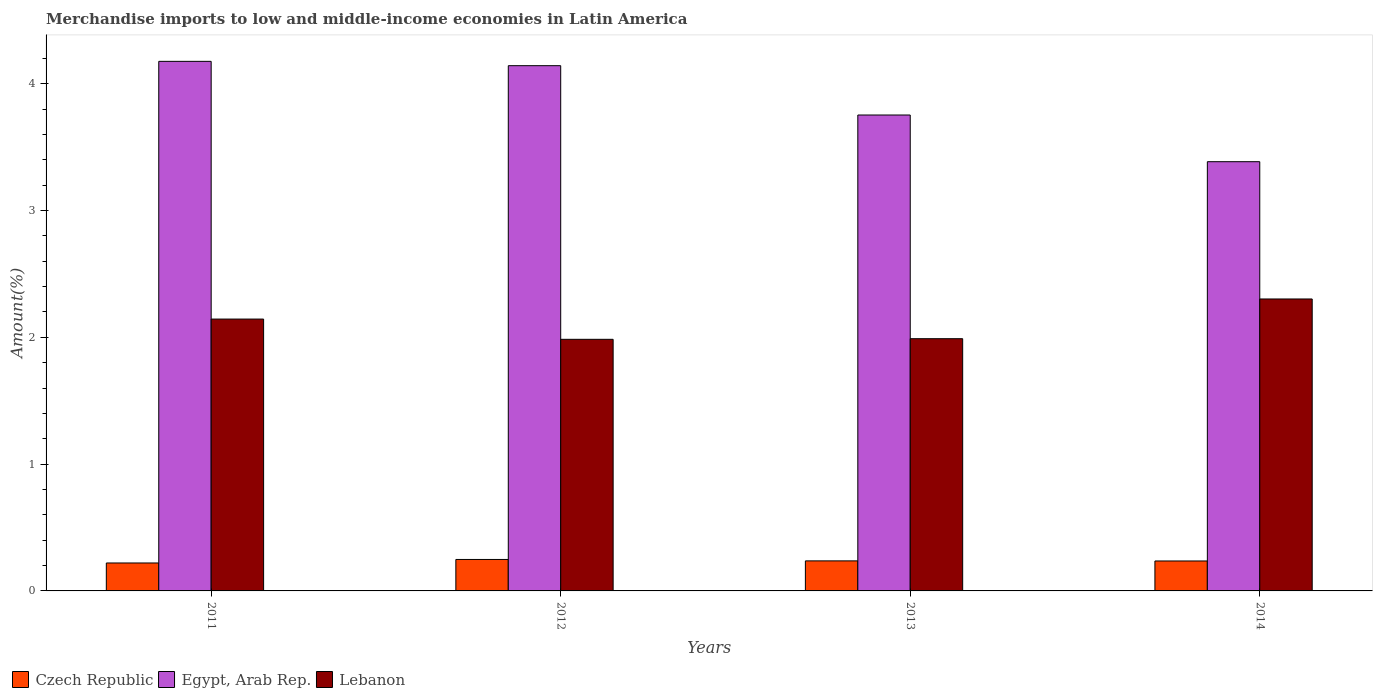How many different coloured bars are there?
Offer a very short reply. 3. How many groups of bars are there?
Ensure brevity in your answer.  4. How many bars are there on the 4th tick from the left?
Your answer should be compact. 3. In how many cases, is the number of bars for a given year not equal to the number of legend labels?
Give a very brief answer. 0. What is the percentage of amount earned from merchandise imports in Czech Republic in 2011?
Give a very brief answer. 0.22. Across all years, what is the maximum percentage of amount earned from merchandise imports in Czech Republic?
Provide a succinct answer. 0.25. Across all years, what is the minimum percentage of amount earned from merchandise imports in Czech Republic?
Provide a succinct answer. 0.22. In which year was the percentage of amount earned from merchandise imports in Lebanon maximum?
Your answer should be very brief. 2014. What is the total percentage of amount earned from merchandise imports in Lebanon in the graph?
Provide a short and direct response. 8.42. What is the difference between the percentage of amount earned from merchandise imports in Czech Republic in 2012 and that in 2014?
Keep it short and to the point. 0.01. What is the difference between the percentage of amount earned from merchandise imports in Lebanon in 2014 and the percentage of amount earned from merchandise imports in Egypt, Arab Rep. in 2013?
Keep it short and to the point. -1.45. What is the average percentage of amount earned from merchandise imports in Egypt, Arab Rep. per year?
Provide a succinct answer. 3.86. In the year 2012, what is the difference between the percentage of amount earned from merchandise imports in Lebanon and percentage of amount earned from merchandise imports in Czech Republic?
Your answer should be compact. 1.74. In how many years, is the percentage of amount earned from merchandise imports in Lebanon greater than 1.2 %?
Provide a succinct answer. 4. What is the ratio of the percentage of amount earned from merchandise imports in Egypt, Arab Rep. in 2011 to that in 2012?
Your response must be concise. 1.01. Is the percentage of amount earned from merchandise imports in Czech Republic in 2011 less than that in 2012?
Ensure brevity in your answer.  Yes. What is the difference between the highest and the second highest percentage of amount earned from merchandise imports in Czech Republic?
Offer a terse response. 0.01. What is the difference between the highest and the lowest percentage of amount earned from merchandise imports in Egypt, Arab Rep.?
Your answer should be very brief. 0.79. Is the sum of the percentage of amount earned from merchandise imports in Lebanon in 2011 and 2013 greater than the maximum percentage of amount earned from merchandise imports in Egypt, Arab Rep. across all years?
Provide a succinct answer. No. What does the 3rd bar from the left in 2012 represents?
Your response must be concise. Lebanon. What does the 1st bar from the right in 2011 represents?
Give a very brief answer. Lebanon. Is it the case that in every year, the sum of the percentage of amount earned from merchandise imports in Egypt, Arab Rep. and percentage of amount earned from merchandise imports in Lebanon is greater than the percentage of amount earned from merchandise imports in Czech Republic?
Your response must be concise. Yes. Are all the bars in the graph horizontal?
Offer a very short reply. No. How many years are there in the graph?
Keep it short and to the point. 4. Does the graph contain grids?
Your answer should be compact. No. How are the legend labels stacked?
Your answer should be compact. Horizontal. What is the title of the graph?
Your response must be concise. Merchandise imports to low and middle-income economies in Latin America. Does "New Zealand" appear as one of the legend labels in the graph?
Provide a succinct answer. No. What is the label or title of the X-axis?
Ensure brevity in your answer.  Years. What is the label or title of the Y-axis?
Ensure brevity in your answer.  Amount(%). What is the Amount(%) of Czech Republic in 2011?
Offer a terse response. 0.22. What is the Amount(%) of Egypt, Arab Rep. in 2011?
Offer a very short reply. 4.18. What is the Amount(%) in Lebanon in 2011?
Your response must be concise. 2.14. What is the Amount(%) of Czech Republic in 2012?
Offer a very short reply. 0.25. What is the Amount(%) of Egypt, Arab Rep. in 2012?
Ensure brevity in your answer.  4.14. What is the Amount(%) in Lebanon in 2012?
Give a very brief answer. 1.98. What is the Amount(%) in Czech Republic in 2013?
Offer a terse response. 0.24. What is the Amount(%) in Egypt, Arab Rep. in 2013?
Offer a very short reply. 3.75. What is the Amount(%) of Lebanon in 2013?
Give a very brief answer. 1.99. What is the Amount(%) in Czech Republic in 2014?
Provide a short and direct response. 0.24. What is the Amount(%) in Egypt, Arab Rep. in 2014?
Keep it short and to the point. 3.39. What is the Amount(%) of Lebanon in 2014?
Ensure brevity in your answer.  2.3. Across all years, what is the maximum Amount(%) in Czech Republic?
Make the answer very short. 0.25. Across all years, what is the maximum Amount(%) in Egypt, Arab Rep.?
Keep it short and to the point. 4.18. Across all years, what is the maximum Amount(%) of Lebanon?
Your answer should be compact. 2.3. Across all years, what is the minimum Amount(%) of Czech Republic?
Offer a very short reply. 0.22. Across all years, what is the minimum Amount(%) of Egypt, Arab Rep.?
Give a very brief answer. 3.39. Across all years, what is the minimum Amount(%) of Lebanon?
Offer a terse response. 1.98. What is the total Amount(%) in Czech Republic in the graph?
Ensure brevity in your answer.  0.94. What is the total Amount(%) in Egypt, Arab Rep. in the graph?
Give a very brief answer. 15.46. What is the total Amount(%) of Lebanon in the graph?
Keep it short and to the point. 8.42. What is the difference between the Amount(%) in Czech Republic in 2011 and that in 2012?
Ensure brevity in your answer.  -0.03. What is the difference between the Amount(%) of Egypt, Arab Rep. in 2011 and that in 2012?
Offer a terse response. 0.03. What is the difference between the Amount(%) of Lebanon in 2011 and that in 2012?
Your answer should be compact. 0.16. What is the difference between the Amount(%) in Czech Republic in 2011 and that in 2013?
Offer a terse response. -0.02. What is the difference between the Amount(%) in Egypt, Arab Rep. in 2011 and that in 2013?
Offer a terse response. 0.42. What is the difference between the Amount(%) in Lebanon in 2011 and that in 2013?
Make the answer very short. 0.15. What is the difference between the Amount(%) of Czech Republic in 2011 and that in 2014?
Offer a terse response. -0.02. What is the difference between the Amount(%) in Egypt, Arab Rep. in 2011 and that in 2014?
Offer a very short reply. 0.79. What is the difference between the Amount(%) of Lebanon in 2011 and that in 2014?
Your answer should be compact. -0.16. What is the difference between the Amount(%) of Czech Republic in 2012 and that in 2013?
Make the answer very short. 0.01. What is the difference between the Amount(%) in Egypt, Arab Rep. in 2012 and that in 2013?
Offer a terse response. 0.39. What is the difference between the Amount(%) of Lebanon in 2012 and that in 2013?
Provide a succinct answer. -0.01. What is the difference between the Amount(%) of Czech Republic in 2012 and that in 2014?
Offer a terse response. 0.01. What is the difference between the Amount(%) of Egypt, Arab Rep. in 2012 and that in 2014?
Provide a short and direct response. 0.76. What is the difference between the Amount(%) of Lebanon in 2012 and that in 2014?
Offer a terse response. -0.32. What is the difference between the Amount(%) in Czech Republic in 2013 and that in 2014?
Offer a very short reply. 0. What is the difference between the Amount(%) in Egypt, Arab Rep. in 2013 and that in 2014?
Your answer should be very brief. 0.37. What is the difference between the Amount(%) in Lebanon in 2013 and that in 2014?
Your answer should be compact. -0.31. What is the difference between the Amount(%) of Czech Republic in 2011 and the Amount(%) of Egypt, Arab Rep. in 2012?
Ensure brevity in your answer.  -3.92. What is the difference between the Amount(%) in Czech Republic in 2011 and the Amount(%) in Lebanon in 2012?
Give a very brief answer. -1.76. What is the difference between the Amount(%) in Egypt, Arab Rep. in 2011 and the Amount(%) in Lebanon in 2012?
Provide a short and direct response. 2.19. What is the difference between the Amount(%) of Czech Republic in 2011 and the Amount(%) of Egypt, Arab Rep. in 2013?
Provide a short and direct response. -3.53. What is the difference between the Amount(%) of Czech Republic in 2011 and the Amount(%) of Lebanon in 2013?
Give a very brief answer. -1.77. What is the difference between the Amount(%) of Egypt, Arab Rep. in 2011 and the Amount(%) of Lebanon in 2013?
Your answer should be very brief. 2.19. What is the difference between the Amount(%) in Czech Republic in 2011 and the Amount(%) in Egypt, Arab Rep. in 2014?
Your answer should be compact. -3.16. What is the difference between the Amount(%) in Czech Republic in 2011 and the Amount(%) in Lebanon in 2014?
Provide a short and direct response. -2.08. What is the difference between the Amount(%) of Egypt, Arab Rep. in 2011 and the Amount(%) of Lebanon in 2014?
Your answer should be very brief. 1.87. What is the difference between the Amount(%) of Czech Republic in 2012 and the Amount(%) of Egypt, Arab Rep. in 2013?
Provide a short and direct response. -3.51. What is the difference between the Amount(%) in Czech Republic in 2012 and the Amount(%) in Lebanon in 2013?
Your answer should be compact. -1.74. What is the difference between the Amount(%) of Egypt, Arab Rep. in 2012 and the Amount(%) of Lebanon in 2013?
Your response must be concise. 2.15. What is the difference between the Amount(%) of Czech Republic in 2012 and the Amount(%) of Egypt, Arab Rep. in 2014?
Give a very brief answer. -3.14. What is the difference between the Amount(%) of Czech Republic in 2012 and the Amount(%) of Lebanon in 2014?
Keep it short and to the point. -2.05. What is the difference between the Amount(%) in Egypt, Arab Rep. in 2012 and the Amount(%) in Lebanon in 2014?
Your response must be concise. 1.84. What is the difference between the Amount(%) of Czech Republic in 2013 and the Amount(%) of Egypt, Arab Rep. in 2014?
Offer a very short reply. -3.15. What is the difference between the Amount(%) of Czech Republic in 2013 and the Amount(%) of Lebanon in 2014?
Keep it short and to the point. -2.07. What is the difference between the Amount(%) in Egypt, Arab Rep. in 2013 and the Amount(%) in Lebanon in 2014?
Offer a very short reply. 1.45. What is the average Amount(%) of Czech Republic per year?
Give a very brief answer. 0.24. What is the average Amount(%) of Egypt, Arab Rep. per year?
Give a very brief answer. 3.86. What is the average Amount(%) of Lebanon per year?
Keep it short and to the point. 2.1. In the year 2011, what is the difference between the Amount(%) in Czech Republic and Amount(%) in Egypt, Arab Rep.?
Keep it short and to the point. -3.96. In the year 2011, what is the difference between the Amount(%) of Czech Republic and Amount(%) of Lebanon?
Ensure brevity in your answer.  -1.92. In the year 2011, what is the difference between the Amount(%) in Egypt, Arab Rep. and Amount(%) in Lebanon?
Ensure brevity in your answer.  2.03. In the year 2012, what is the difference between the Amount(%) of Czech Republic and Amount(%) of Egypt, Arab Rep.?
Make the answer very short. -3.89. In the year 2012, what is the difference between the Amount(%) in Czech Republic and Amount(%) in Lebanon?
Keep it short and to the point. -1.74. In the year 2012, what is the difference between the Amount(%) in Egypt, Arab Rep. and Amount(%) in Lebanon?
Your answer should be very brief. 2.16. In the year 2013, what is the difference between the Amount(%) in Czech Republic and Amount(%) in Egypt, Arab Rep.?
Make the answer very short. -3.52. In the year 2013, what is the difference between the Amount(%) of Czech Republic and Amount(%) of Lebanon?
Keep it short and to the point. -1.75. In the year 2013, what is the difference between the Amount(%) in Egypt, Arab Rep. and Amount(%) in Lebanon?
Offer a terse response. 1.76. In the year 2014, what is the difference between the Amount(%) of Czech Republic and Amount(%) of Egypt, Arab Rep.?
Your response must be concise. -3.15. In the year 2014, what is the difference between the Amount(%) in Czech Republic and Amount(%) in Lebanon?
Offer a terse response. -2.07. In the year 2014, what is the difference between the Amount(%) in Egypt, Arab Rep. and Amount(%) in Lebanon?
Offer a terse response. 1.08. What is the ratio of the Amount(%) in Czech Republic in 2011 to that in 2012?
Make the answer very short. 0.89. What is the ratio of the Amount(%) in Egypt, Arab Rep. in 2011 to that in 2012?
Ensure brevity in your answer.  1.01. What is the ratio of the Amount(%) in Lebanon in 2011 to that in 2012?
Keep it short and to the point. 1.08. What is the ratio of the Amount(%) of Czech Republic in 2011 to that in 2013?
Offer a very short reply. 0.93. What is the ratio of the Amount(%) in Egypt, Arab Rep. in 2011 to that in 2013?
Offer a terse response. 1.11. What is the ratio of the Amount(%) of Lebanon in 2011 to that in 2013?
Give a very brief answer. 1.08. What is the ratio of the Amount(%) of Czech Republic in 2011 to that in 2014?
Your answer should be compact. 0.93. What is the ratio of the Amount(%) in Egypt, Arab Rep. in 2011 to that in 2014?
Give a very brief answer. 1.23. What is the ratio of the Amount(%) in Lebanon in 2011 to that in 2014?
Your answer should be very brief. 0.93. What is the ratio of the Amount(%) of Czech Republic in 2012 to that in 2013?
Your answer should be compact. 1.05. What is the ratio of the Amount(%) of Egypt, Arab Rep. in 2012 to that in 2013?
Your answer should be very brief. 1.1. What is the ratio of the Amount(%) of Lebanon in 2012 to that in 2013?
Offer a terse response. 1. What is the ratio of the Amount(%) in Czech Republic in 2012 to that in 2014?
Your answer should be very brief. 1.05. What is the ratio of the Amount(%) in Egypt, Arab Rep. in 2012 to that in 2014?
Offer a very short reply. 1.22. What is the ratio of the Amount(%) in Lebanon in 2012 to that in 2014?
Ensure brevity in your answer.  0.86. What is the ratio of the Amount(%) in Czech Republic in 2013 to that in 2014?
Ensure brevity in your answer.  1. What is the ratio of the Amount(%) in Egypt, Arab Rep. in 2013 to that in 2014?
Provide a short and direct response. 1.11. What is the ratio of the Amount(%) in Lebanon in 2013 to that in 2014?
Keep it short and to the point. 0.86. What is the difference between the highest and the second highest Amount(%) in Czech Republic?
Offer a very short reply. 0.01. What is the difference between the highest and the second highest Amount(%) in Egypt, Arab Rep.?
Provide a succinct answer. 0.03. What is the difference between the highest and the second highest Amount(%) in Lebanon?
Offer a very short reply. 0.16. What is the difference between the highest and the lowest Amount(%) in Czech Republic?
Keep it short and to the point. 0.03. What is the difference between the highest and the lowest Amount(%) in Egypt, Arab Rep.?
Offer a terse response. 0.79. What is the difference between the highest and the lowest Amount(%) of Lebanon?
Provide a succinct answer. 0.32. 